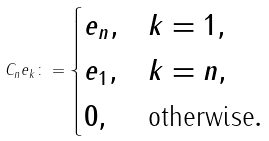<formula> <loc_0><loc_0><loc_500><loc_500>C _ { n } e _ { k } \colon = \begin{cases} e _ { n } , & k = 1 , \\ e _ { 1 } , & k = n , \\ 0 , & \text {otherwise} . \end{cases}</formula> 